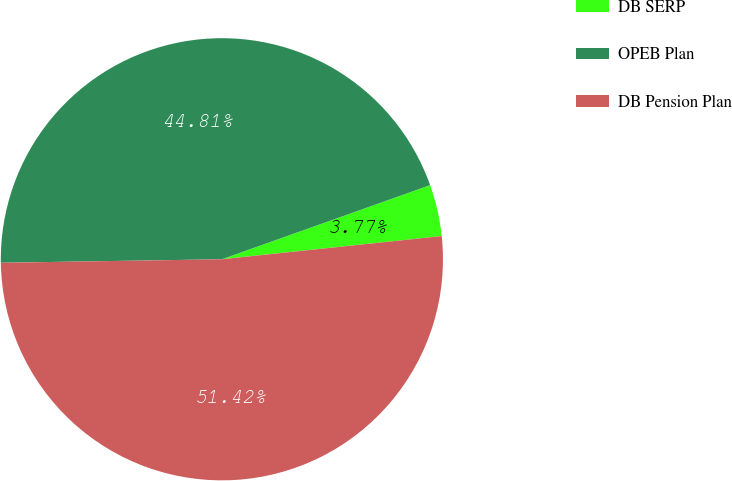<chart> <loc_0><loc_0><loc_500><loc_500><pie_chart><fcel>DB SERP<fcel>OPEB Plan<fcel>DB Pension Plan<nl><fcel>3.77%<fcel>44.81%<fcel>51.42%<nl></chart> 